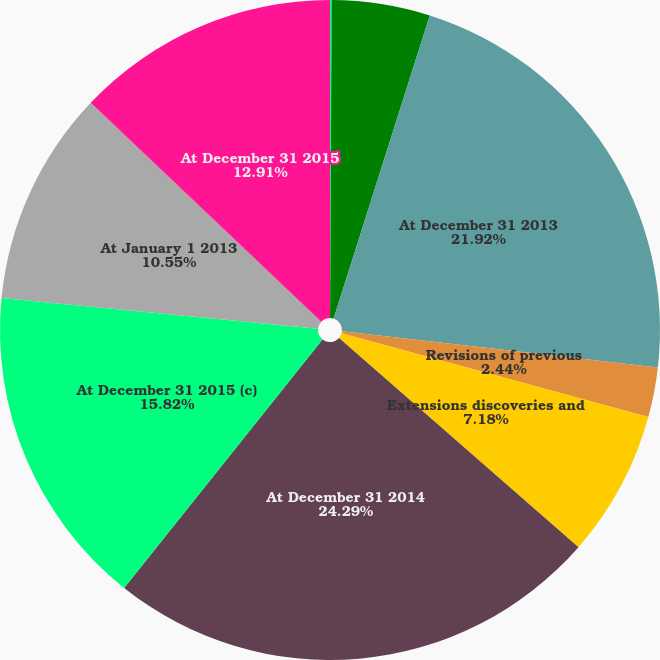Convert chart to OTSL. <chart><loc_0><loc_0><loc_500><loc_500><pie_chart><fcel>Sales of minerals in place<fcel>Production (f)<fcel>At December 31 2013<fcel>Revisions of previous<fcel>Extensions discoveries and<fcel>At December 31 2014<fcel>At December 31 2015 (c)<fcel>At January 1 2013<fcel>At December 31 2015<nl><fcel>0.08%<fcel>4.81%<fcel>21.92%<fcel>2.44%<fcel>7.18%<fcel>24.29%<fcel>15.82%<fcel>10.55%<fcel>12.91%<nl></chart> 